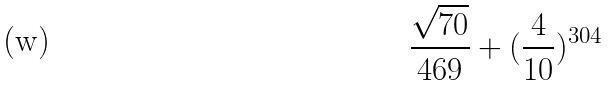<formula> <loc_0><loc_0><loc_500><loc_500>\frac { \sqrt { 7 0 } } { 4 6 9 } + ( \frac { 4 } { 1 0 } ) ^ { 3 0 4 }</formula> 